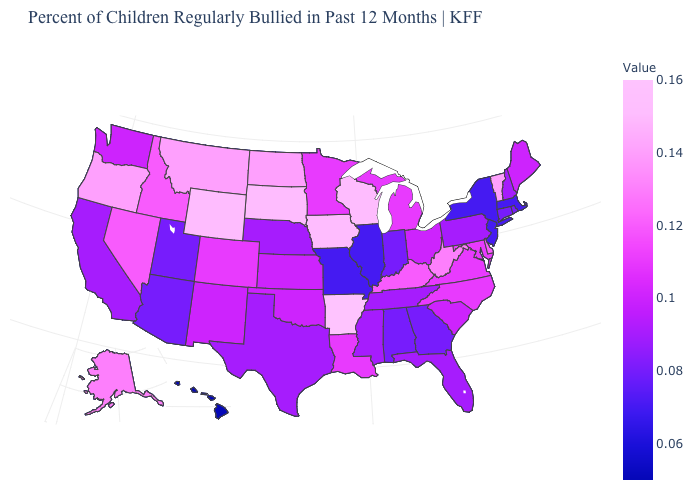Among the states that border Vermont , which have the highest value?
Short answer required. New Hampshire. Does Kentucky have a lower value than Arkansas?
Be succinct. Yes. Among the states that border Virginia , does Maryland have the lowest value?
Quick response, please. No. Which states have the lowest value in the USA?
Be succinct. Hawaii. Among the states that border South Carolina , does Georgia have the lowest value?
Concise answer only. Yes. Which states have the lowest value in the Northeast?
Give a very brief answer. Massachusetts, New Jersey, New York. Which states hav the highest value in the MidWest?
Short answer required. Iowa, South Dakota, Wisconsin. Among the states that border Iowa , which have the lowest value?
Answer briefly. Illinois, Missouri. 